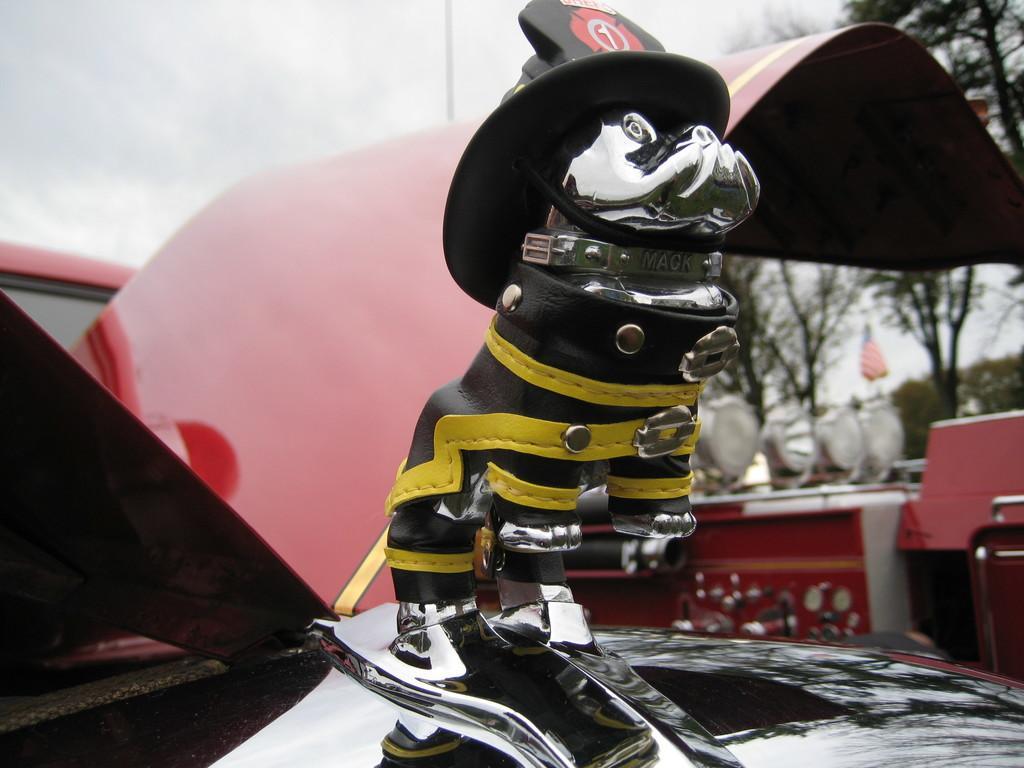Describe this image in one or two sentences. There is a vehicle with a logo. On the logo there is a cap. In the background it is blurred. There are trees, lights, flag and sky in the background. 